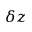Convert formula to latex. <formula><loc_0><loc_0><loc_500><loc_500>\delta z</formula> 